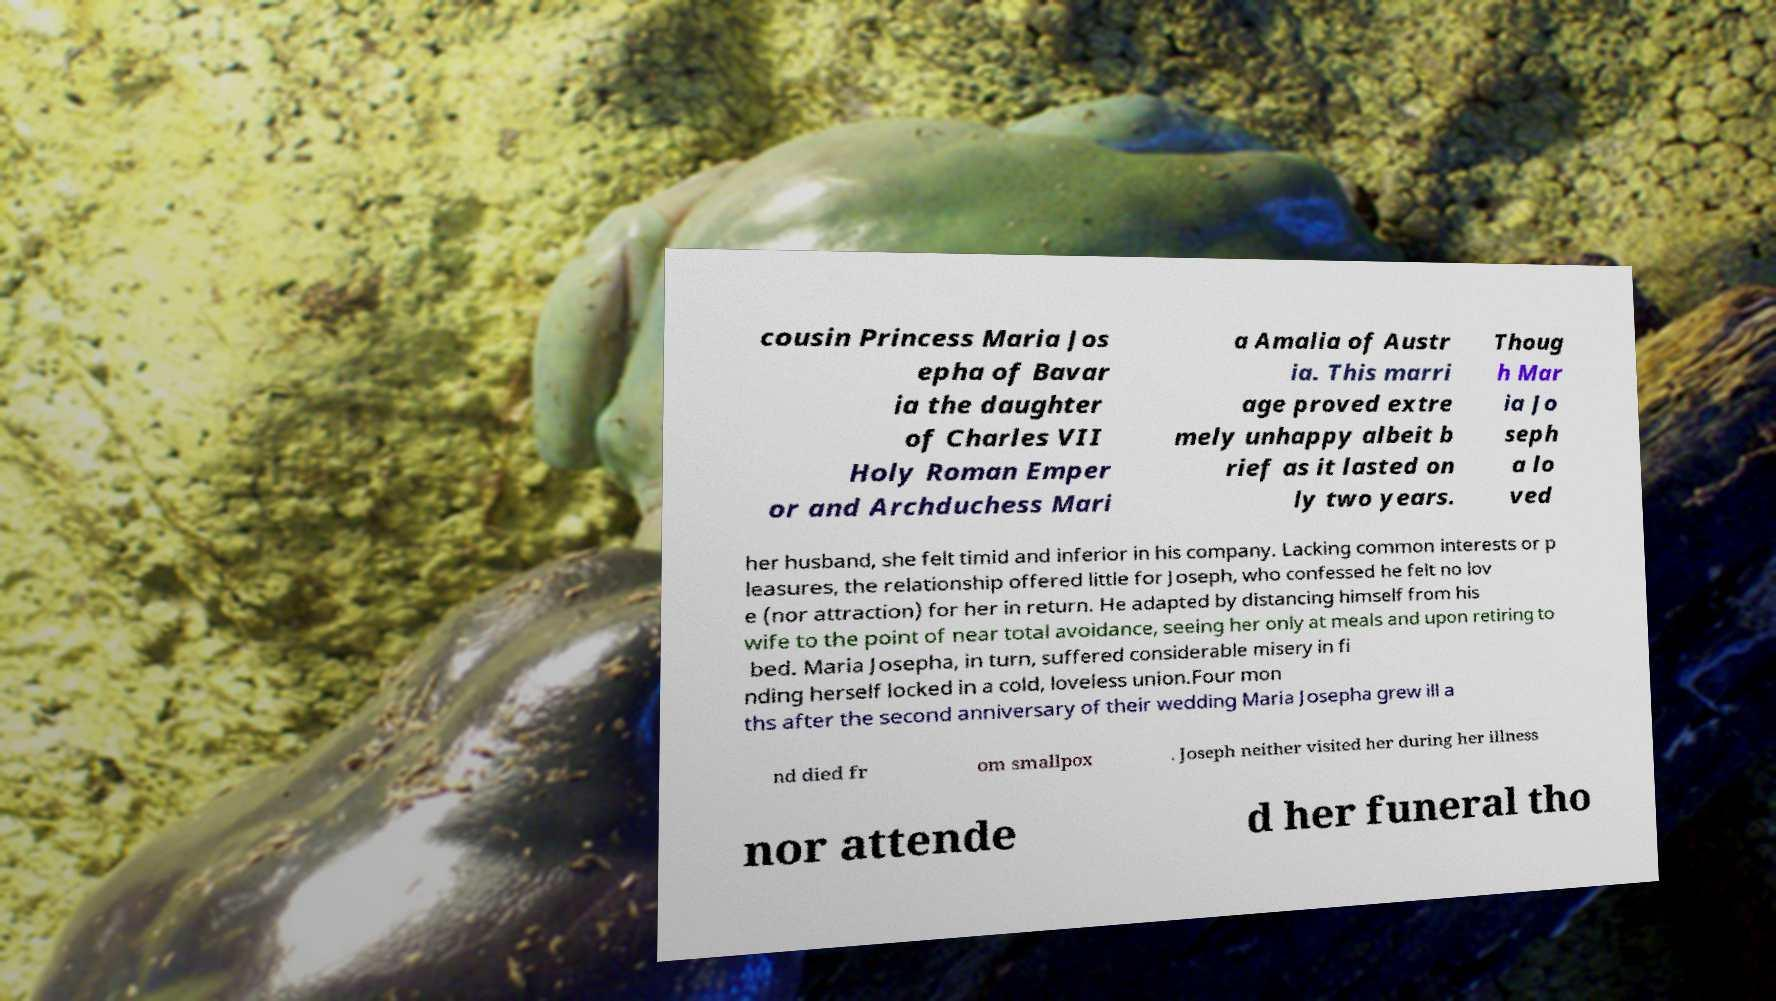I need the written content from this picture converted into text. Can you do that? cousin Princess Maria Jos epha of Bavar ia the daughter of Charles VII Holy Roman Emper or and Archduchess Mari a Amalia of Austr ia. This marri age proved extre mely unhappy albeit b rief as it lasted on ly two years. Thoug h Mar ia Jo seph a lo ved her husband, she felt timid and inferior in his company. Lacking common interests or p leasures, the relationship offered little for Joseph, who confessed he felt no lov e (nor attraction) for her in return. He adapted by distancing himself from his wife to the point of near total avoidance, seeing her only at meals and upon retiring to bed. Maria Josepha, in turn, suffered considerable misery in fi nding herself locked in a cold, loveless union.Four mon ths after the second anniversary of their wedding Maria Josepha grew ill a nd died fr om smallpox . Joseph neither visited her during her illness nor attende d her funeral tho 